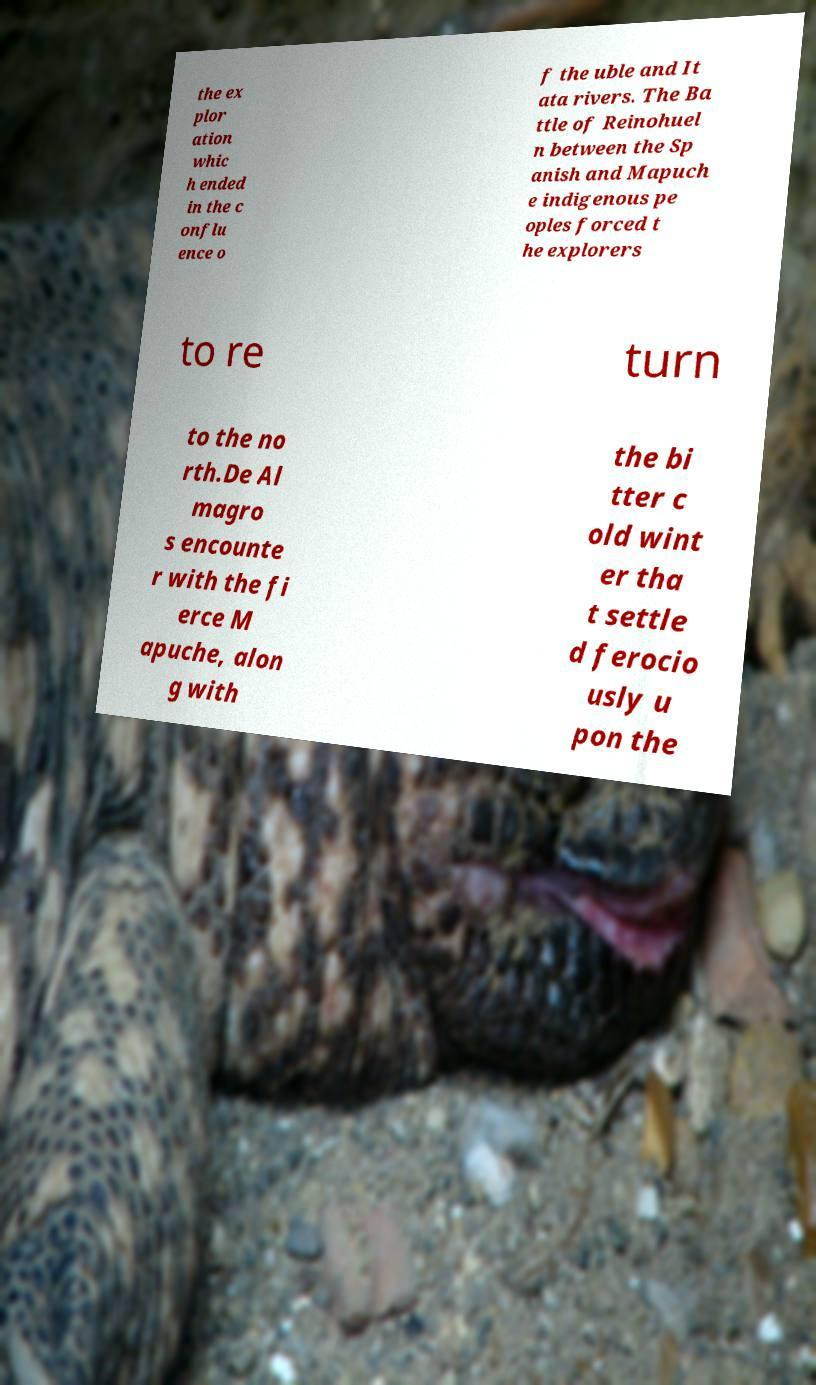Can you accurately transcribe the text from the provided image for me? the ex plor ation whic h ended in the c onflu ence o f the uble and It ata rivers. The Ba ttle of Reinohuel n between the Sp anish and Mapuch e indigenous pe oples forced t he explorers to re turn to the no rth.De Al magro s encounte r with the fi erce M apuche, alon g with the bi tter c old wint er tha t settle d ferocio usly u pon the 